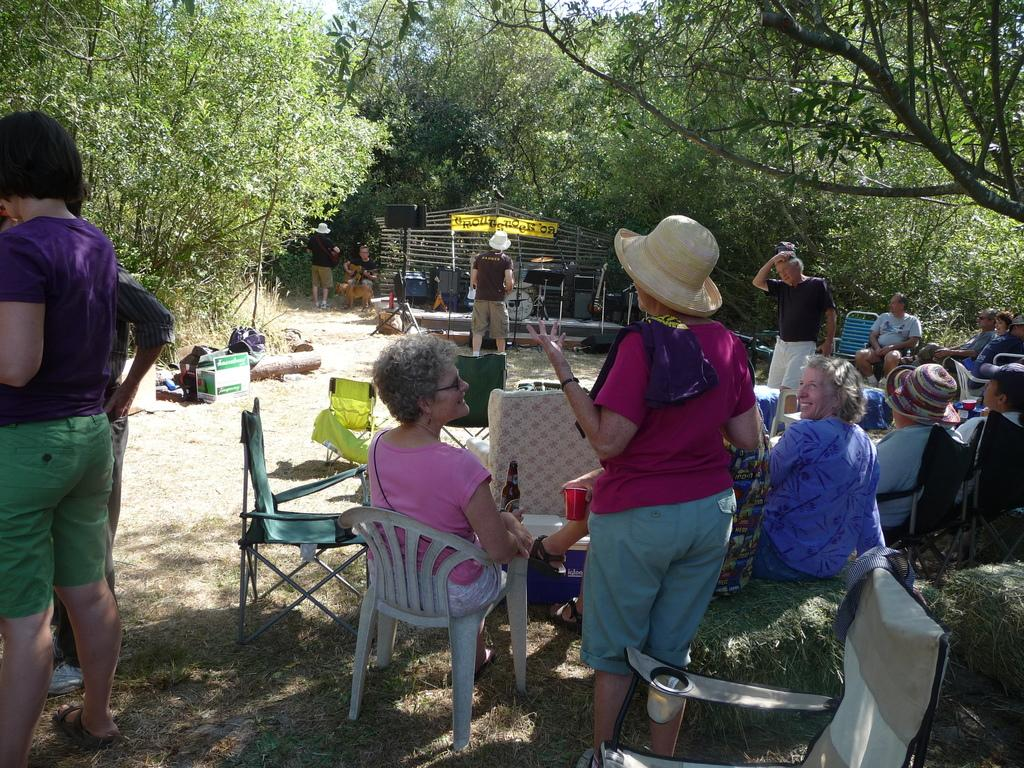What are the people in the image doing? There is a group of people seated on chairs, and there are people standing in the image. What can be seen in the background of the image? There are trees visible in the image. Can you describe the woman in the image? There is a woman holding a glass in her hand in the image. What type of request does the monkey make to the group of people in the image? There is no monkey present in the image, so it is not possible to answer that question. 